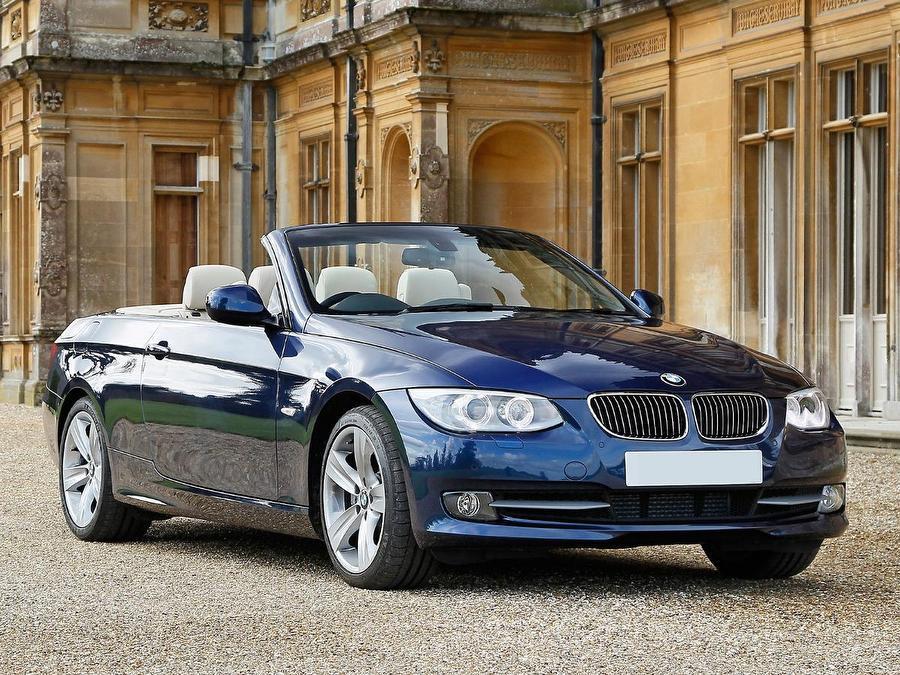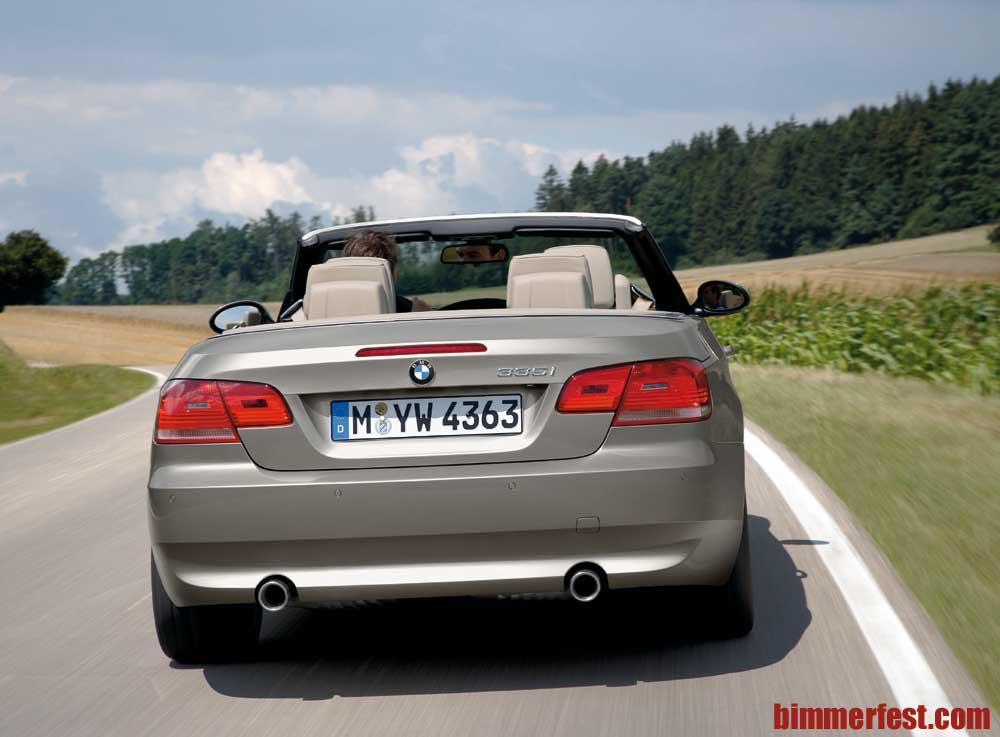The first image is the image on the left, the second image is the image on the right. For the images displayed, is the sentence "In one of the images, the top of the convertible car is in the middle of coming up or down" factually correct? Answer yes or no. No. 